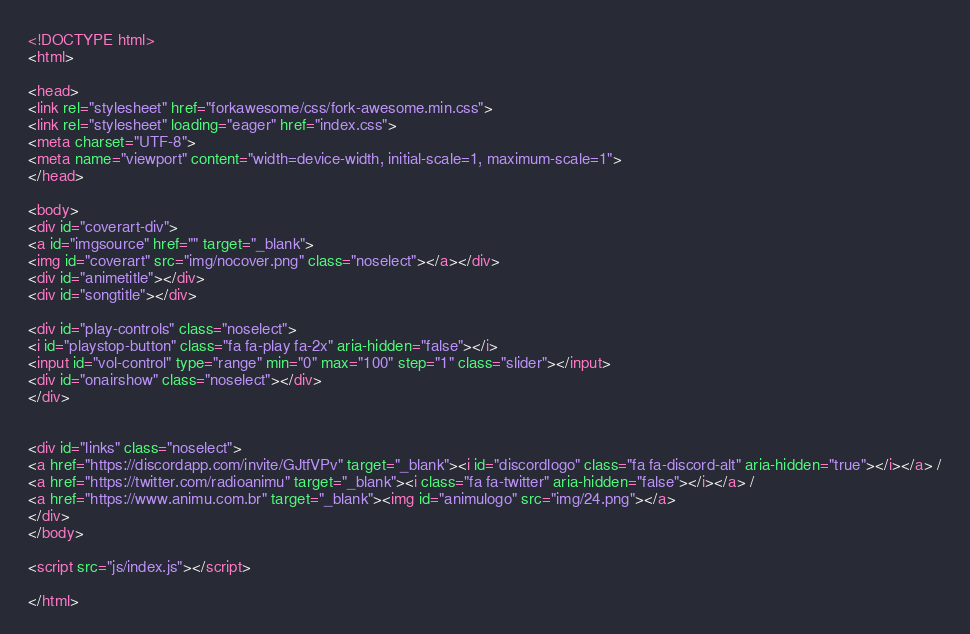Convert code to text. <code><loc_0><loc_0><loc_500><loc_500><_HTML_><!DOCTYPE html>
<html>

<head>
<link rel="stylesheet" href="forkawesome/css/fork-awesome.min.css">
<link rel="stylesheet" loading="eager" href="index.css">
<meta charset="UTF-8"> 
<meta name="viewport" content="width=device-width, initial-scale=1, maximum-scale=1">
</head>

<body>
<div id="coverart-div">
<a id="imgsource" href="" target="_blank">
<img id="coverart" src="img/nocover.png" class="noselect"></a></div>
<div id="animetitle"></div>
<div id="songtitle"></div>

<div id="play-controls" class="noselect">
<i id="playstop-button" class="fa fa-play fa-2x" aria-hidden="false"></i>
<input id="vol-control" type="range" min="0" max="100" step="1" class="slider"></input>
<div id="onairshow" class="noselect"></div>
</div>


<div id="links" class="noselect">
<a href="https://discordapp.com/invite/GJtfVPv" target="_blank"><i id="discordlogo" class="fa fa-discord-alt" aria-hidden="true"></i></a> /
<a href="https://twitter.com/radioanimu" target="_blank"><i class="fa fa-twitter" aria-hidden="false"></i></a> /
<a href="https://www.animu.com.br" target="_blank"><img id="animulogo" src="img/24.png"></a>
</div>
</body>

<script src="js/index.js"></script>

</html>
</code> 